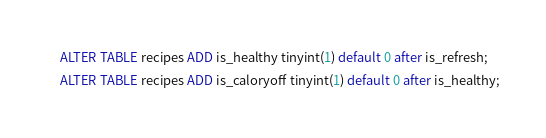Convert code to text. <code><loc_0><loc_0><loc_500><loc_500><_SQL_>ALTER TABLE recipes ADD is_healthy tinyint(1) default 0 after is_refresh;
ALTER TABLE recipes ADD is_caloryoff tinyint(1) default 0 after is_healthy;
</code> 